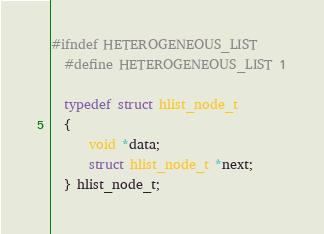Convert code to text. <code><loc_0><loc_0><loc_500><loc_500><_C_>#ifndef HETEROGENEOUS_LIST
  #define HETEROGENEOUS_LIST 1

  typedef struct hlist_node_t
  {
      void *data;
      struct hlist_node_t *next;
  } hlist_node_t;
</code> 